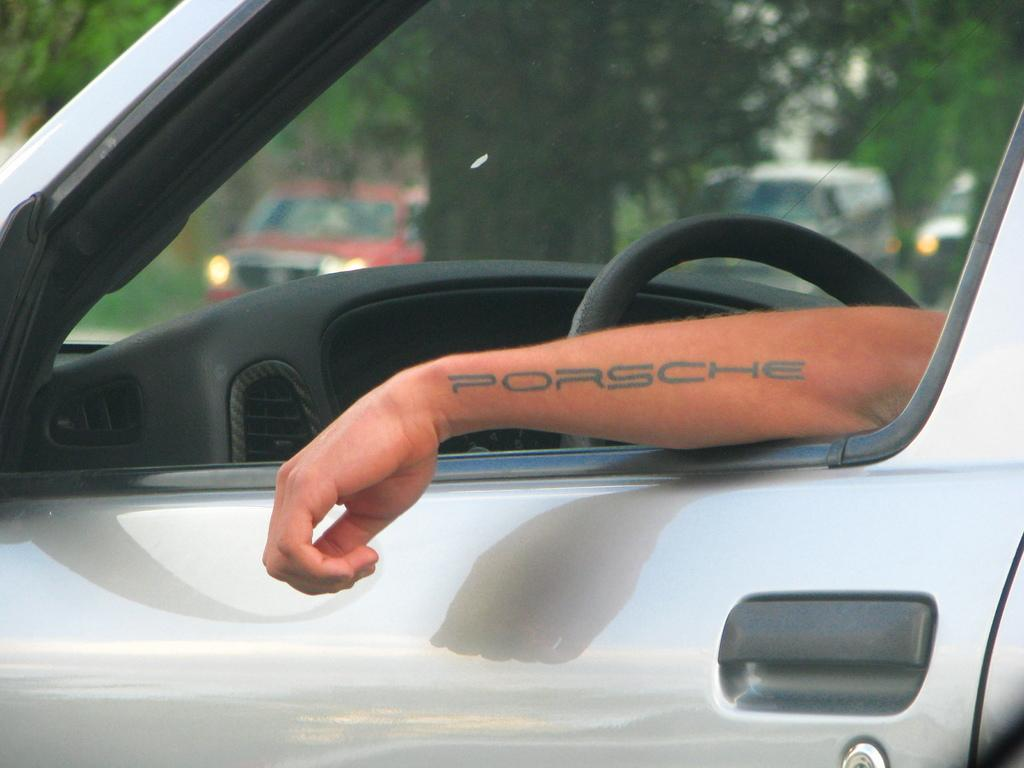What is on the hand of the person in the image? There is a tattoo on the hand of the person in the image. Where is the person located in the image? The person is inside a car. What can be seen in the background of the image? There are vehicles and trees in the background of the image. How does the person in the image react to the sneeze of their father? There is no indication of a sneeze or a father present in the image. 